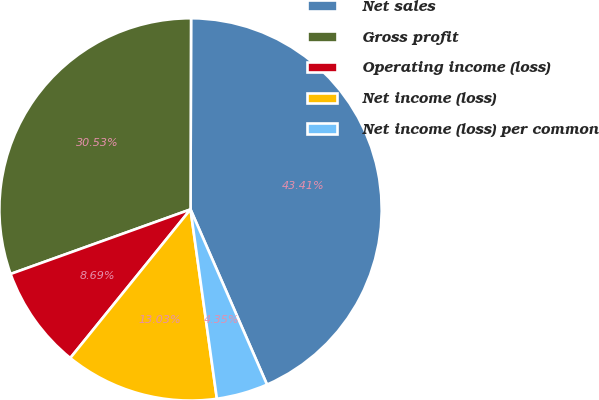Convert chart to OTSL. <chart><loc_0><loc_0><loc_500><loc_500><pie_chart><fcel>Net sales<fcel>Gross profit<fcel>Operating income (loss)<fcel>Net income (loss)<fcel>Net income (loss) per common<nl><fcel>43.41%<fcel>30.53%<fcel>8.69%<fcel>13.03%<fcel>4.35%<nl></chart> 